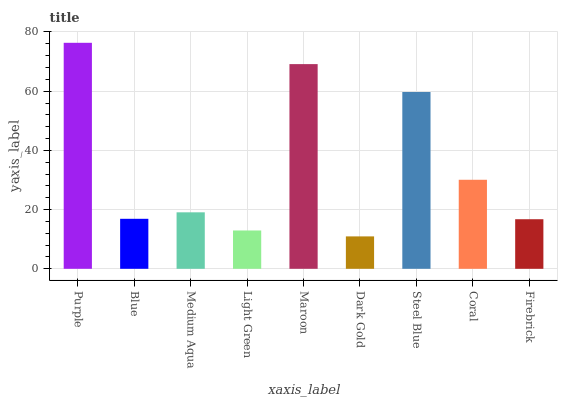Is Dark Gold the minimum?
Answer yes or no. Yes. Is Purple the maximum?
Answer yes or no. Yes. Is Blue the minimum?
Answer yes or no. No. Is Blue the maximum?
Answer yes or no. No. Is Purple greater than Blue?
Answer yes or no. Yes. Is Blue less than Purple?
Answer yes or no. Yes. Is Blue greater than Purple?
Answer yes or no. No. Is Purple less than Blue?
Answer yes or no. No. Is Medium Aqua the high median?
Answer yes or no. Yes. Is Medium Aqua the low median?
Answer yes or no. Yes. Is Purple the high median?
Answer yes or no. No. Is Blue the low median?
Answer yes or no. No. 